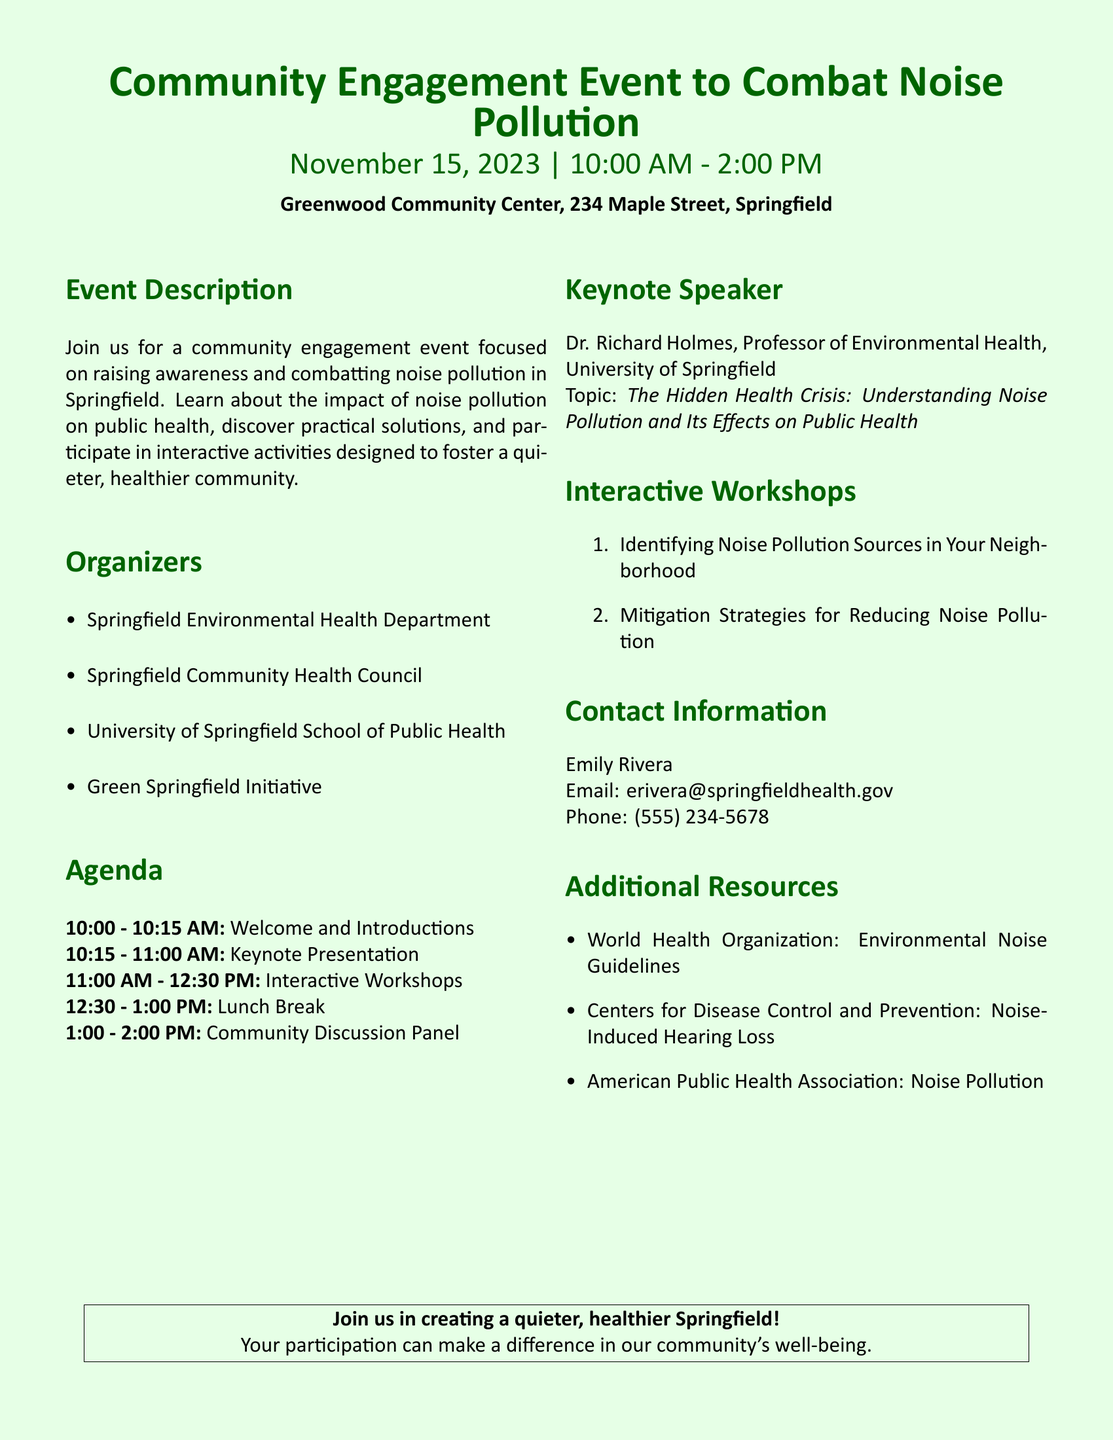What is the event's date? The date of the event is explicitly mentioned in the document as November 15, 2023.
Answer: November 15, 2023 What is the location of the event? The document provides the specific address for the event, which is Greenwood Community Center, 234 Maple Street, Springfield.
Answer: Greenwood Community Center, 234 Maple Street, Springfield Who is the keynote speaker? The keynote speaker is listed in the document as Dr. Richard Holmes.
Answer: Dr. Richard Holmes What time does the event start? The starting time of the event is stated in the agenda section of the document as 10:00 AM.
Answer: 10:00 AM What is one of the interactive workshop topics? The document lists "Identifying Noise Pollution Sources in Your Neighborhood" as one of the workshop topics.
Answer: Identifying Noise Pollution Sources in Your Neighborhood How long is the lunch break? The duration of the lunch break is specified in the agenda, which is 30 minutes.
Answer: 30 minutes What organization is responsible for the event? The Springfield Environmental Health Department is mentioned as one of the organizers in the document.
Answer: Springfield Environmental Health Department What is the main topic of the keynote presentation? The document states that the keynote presentation's topic is "The Hidden Health Crisis: Understanding Noise Pollution and Its Effects on Public Health."
Answer: The Hidden Health Crisis: Understanding Noise Pollution and Its Effects on Public Health Who should be contacted for more information? The document provides contact details for Emily Rivera as the person to contact for more information.
Answer: Emily Rivera 